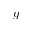<formula> <loc_0><loc_0><loc_500><loc_500>g</formula> 